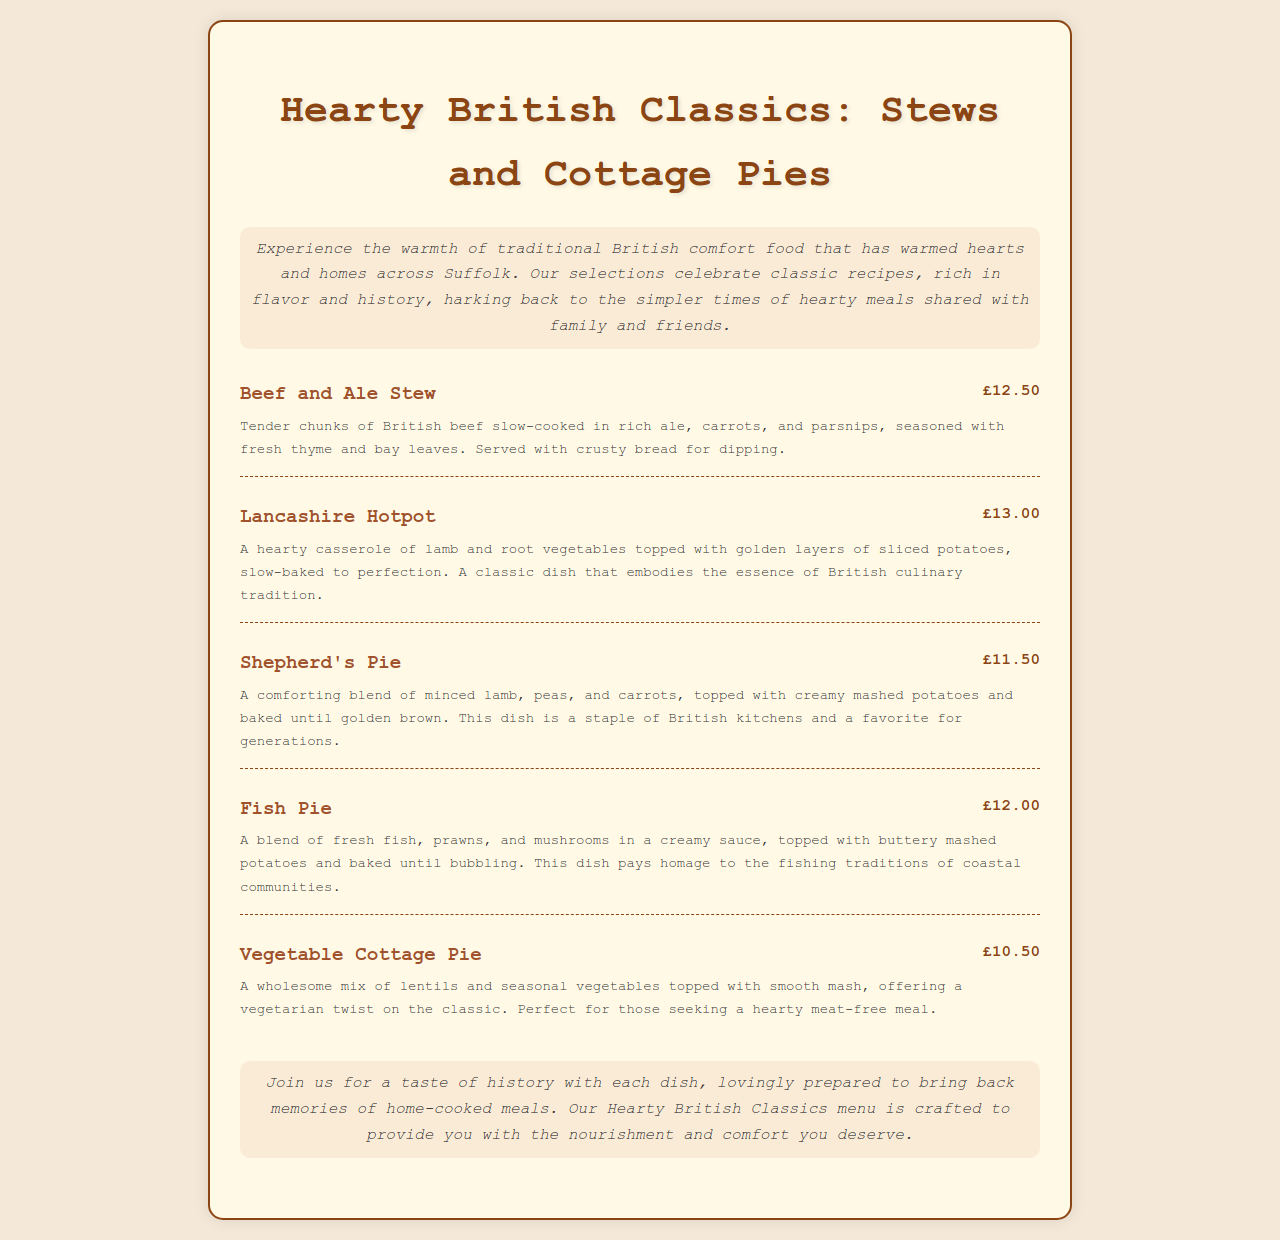What is the title of the menu? The title is prominently displayed at the top of the document.
Answer: Hearty British Classics: Stews and Cottage Pies What is the price of the Lancashire Hotpot? The price is listed next to the dish name in the menu.
Answer: £13.00 What main ingredient is used in the Beef and Ale Stew? The main ingredient is mentioned in the dish description.
Answer: British beef How much does the Vegetable Cottage Pie cost? The price is indicated in the menu next to the dish name.
Answer: £10.50 Which dish features a combination of fresh fish, prawns, and mushrooms? The description of the dish specifies its contents.
Answer: Fish Pie What type of pie is Shepherd's Pie? The name of the dish indicates its classification as a pie.
Answer: Cottage pie What is a vegetarian option on the menu? The description highlights which dish is suitable for vegetarians.
Answer: Vegetable Cottage Pie How is the Beef and Ale Stew served? The serving suggestion is mentioned in the dish description.
Answer: With crusty bread for dipping What is the primary cooking method for the Lancashire Hotpot? The method is inferred from the description of how the dish is prepared.
Answer: Slow-baked 